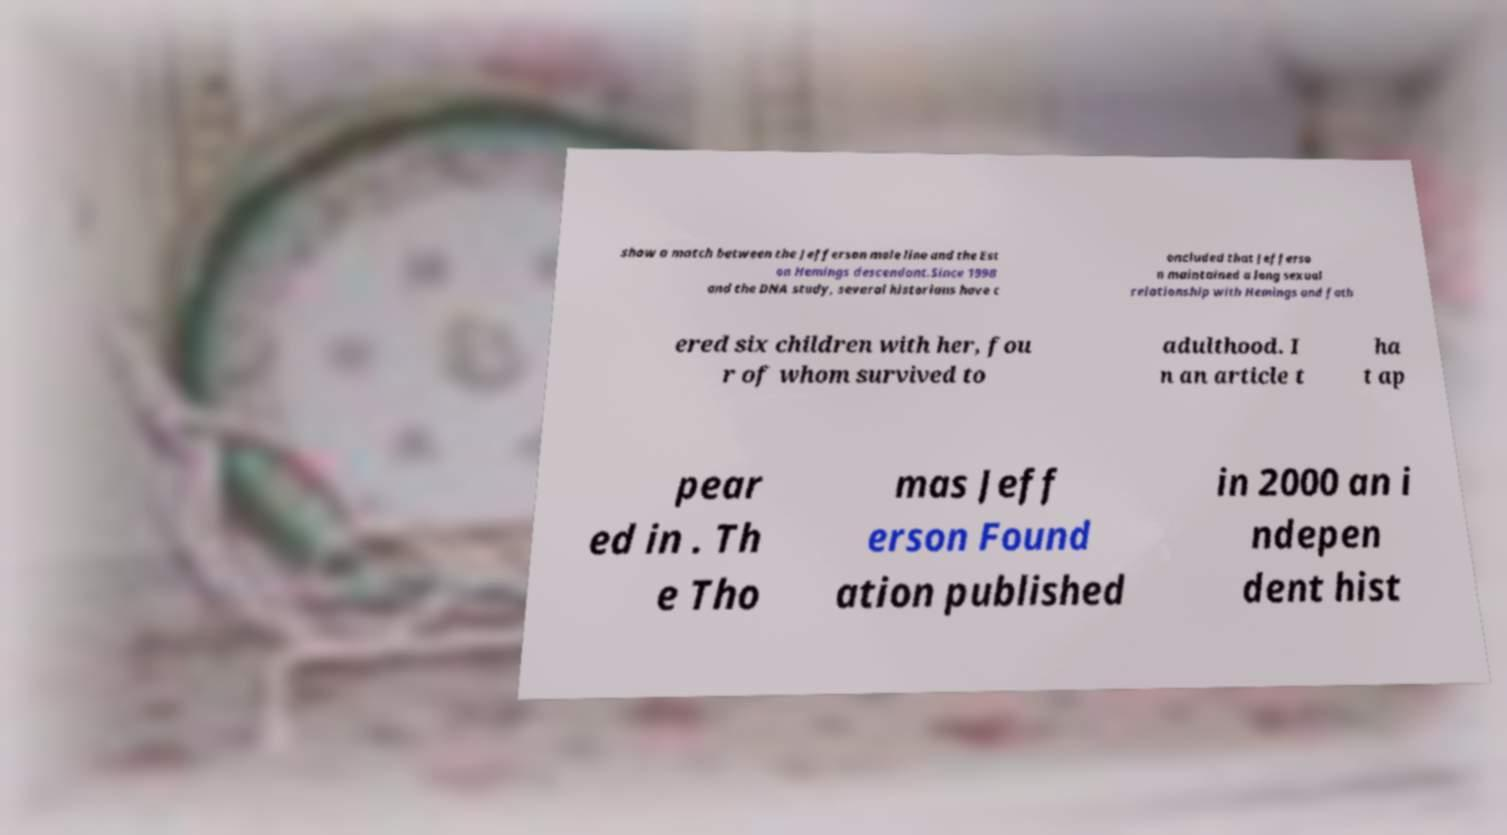Could you extract and type out the text from this image? show a match between the Jefferson male line and the Est on Hemings descendant.Since 1998 and the DNA study, several historians have c oncluded that Jefferso n maintained a long sexual relationship with Hemings and fath ered six children with her, fou r of whom survived to adulthood. I n an article t ha t ap pear ed in . Th e Tho mas Jeff erson Found ation published in 2000 an i ndepen dent hist 